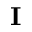<formula> <loc_0><loc_0><loc_500><loc_500>I</formula> 